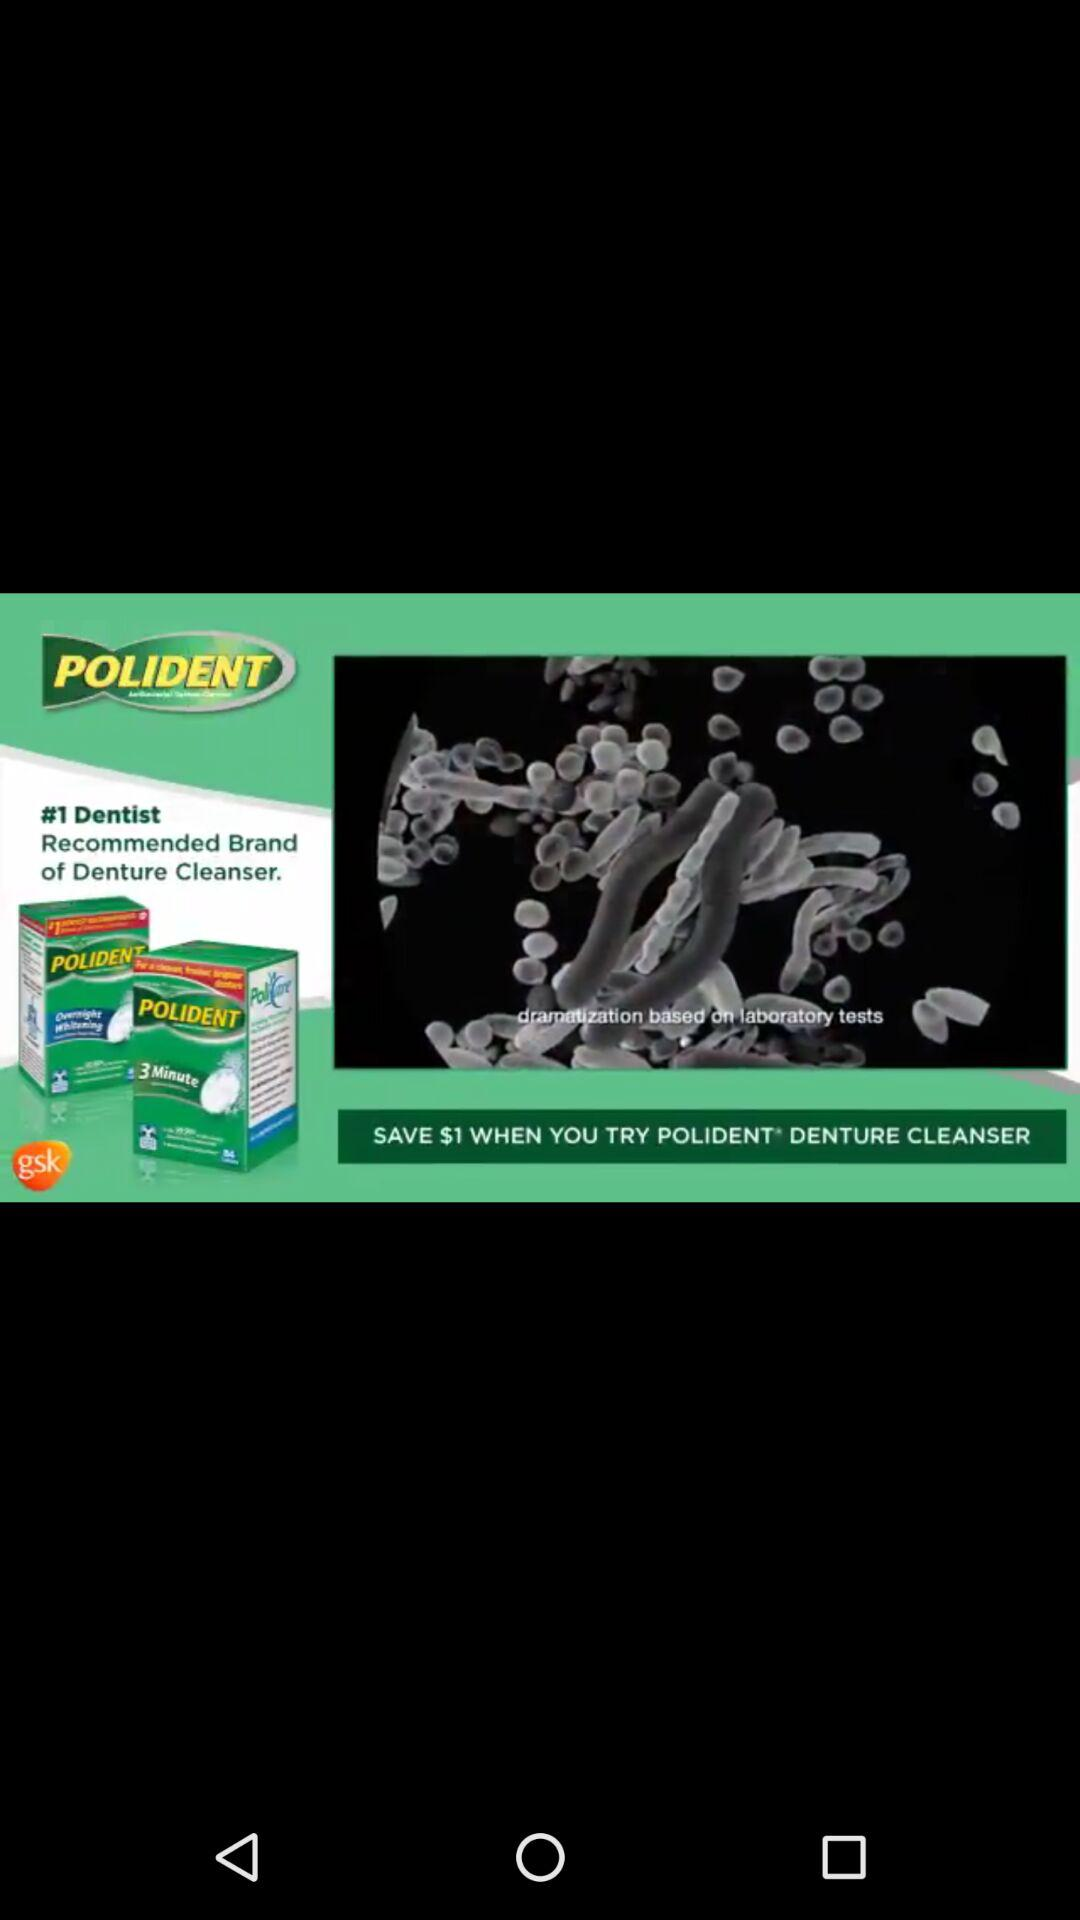How many more dollars are saved by using this product than the regular price?
Answer the question using a single word or phrase. $1 